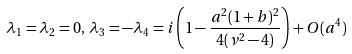Convert formula to latex. <formula><loc_0><loc_0><loc_500><loc_500>\lambda _ { 1 } = \lambda _ { 2 } = 0 , \, \lambda _ { 3 } = - \lambda _ { 4 } = i \left ( 1 - \frac { a ^ { 2 } ( 1 + b ) ^ { 2 } } { 4 ( \nu ^ { 2 } - 4 ) } \right ) + O ( a ^ { 4 } )</formula> 